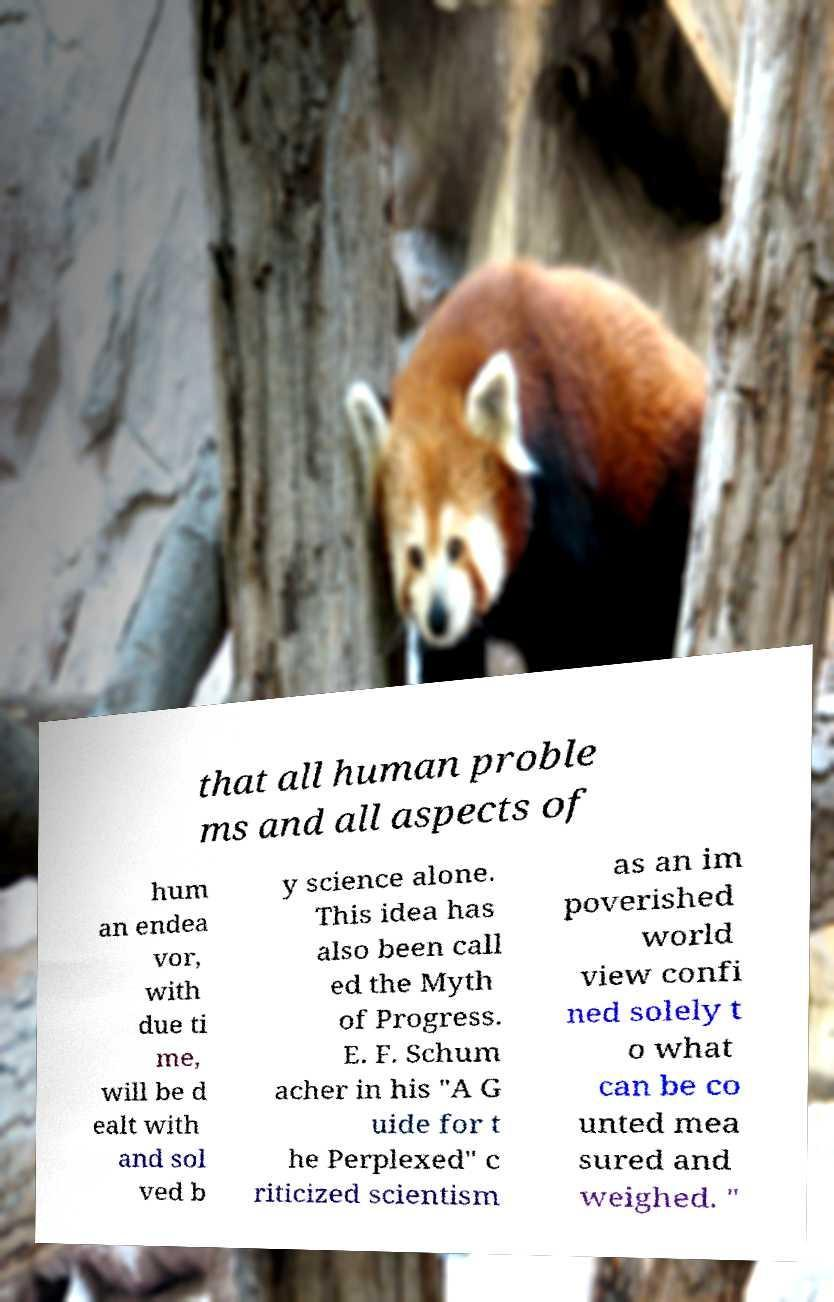Please identify and transcribe the text found in this image. that all human proble ms and all aspects of hum an endea vor, with due ti me, will be d ealt with and sol ved b y science alone. This idea has also been call ed the Myth of Progress. E. F. Schum acher in his "A G uide for t he Perplexed" c riticized scientism as an im poverished world view confi ned solely t o what can be co unted mea sured and weighed. " 